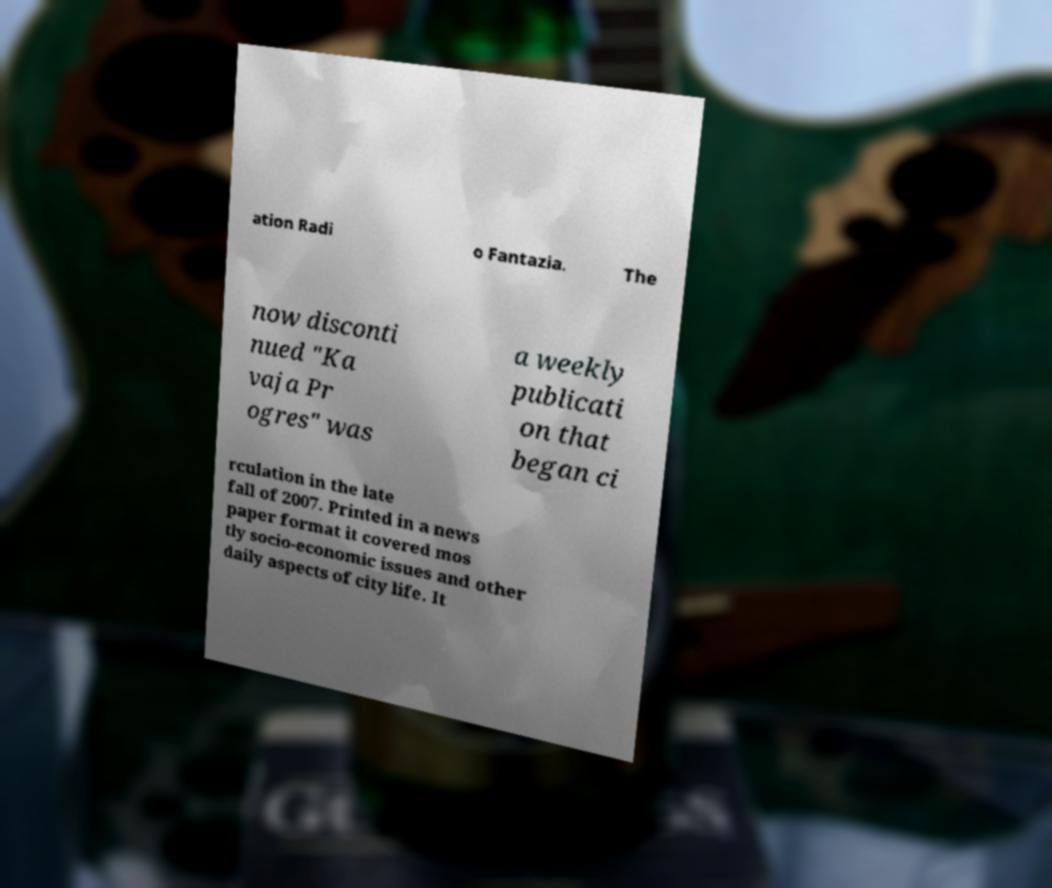Can you read and provide the text displayed in the image?This photo seems to have some interesting text. Can you extract and type it out for me? ation Radi o Fantazia. The now disconti nued "Ka vaja Pr ogres" was a weekly publicati on that began ci rculation in the late fall of 2007. Printed in a news paper format it covered mos tly socio-economic issues and other daily aspects of city life. It 